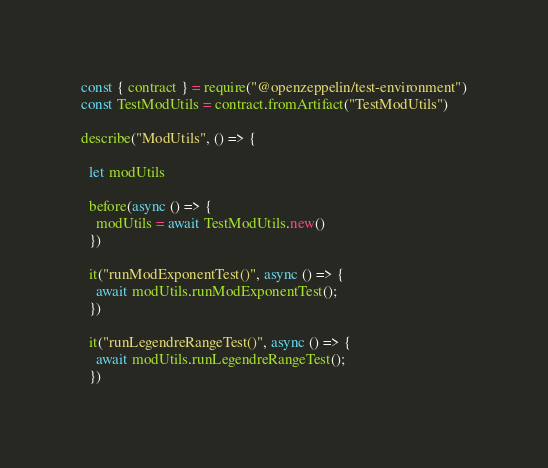<code> <loc_0><loc_0><loc_500><loc_500><_JavaScript_>const { contract } = require("@openzeppelin/test-environment")
const TestModUtils = contract.fromArtifact("TestModUtils")

describe("ModUtils", () => {

  let modUtils

  before(async () => {
    modUtils = await TestModUtils.new()
  })

  it("runModExponentTest()", async () => {
    await modUtils.runModExponentTest();
  })

  it("runLegendreRangeTest()", async () => {
    await modUtils.runLegendreRangeTest();
  })
</code> 